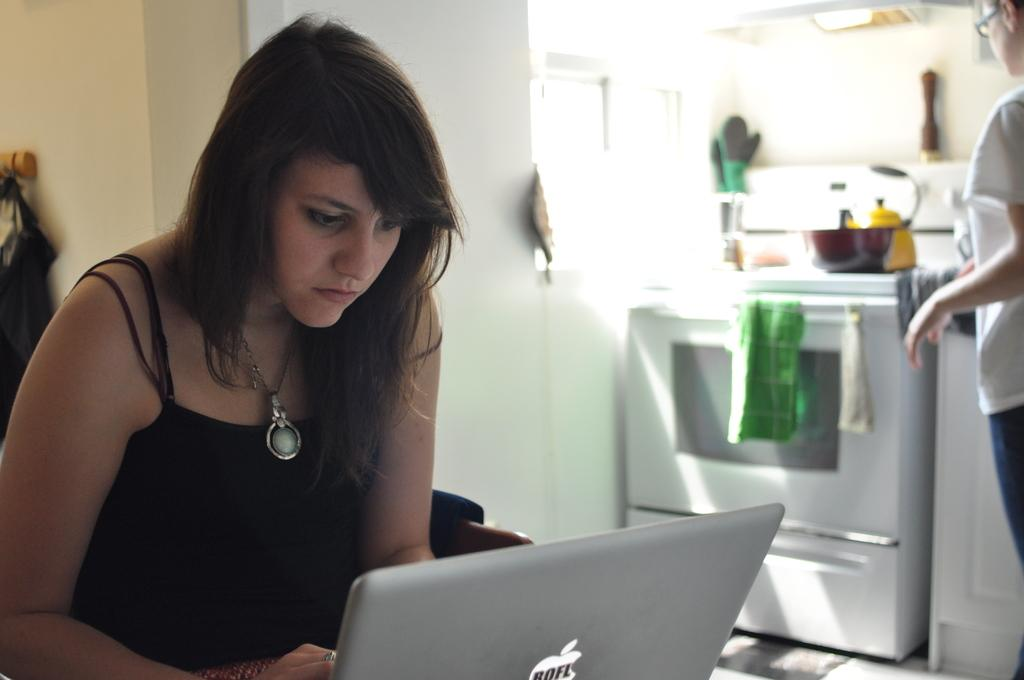<image>
Present a compact description of the photo's key features. A woman's laptop says ROFL on its Apple logo. 